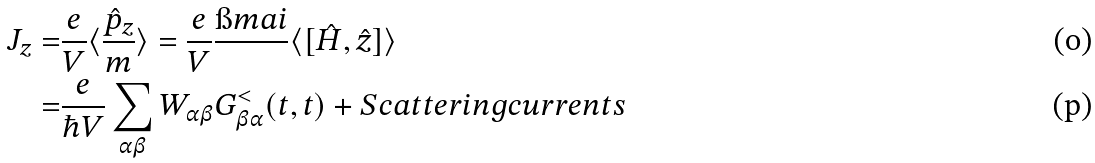Convert formula to latex. <formula><loc_0><loc_0><loc_500><loc_500>J _ { z } = & \frac { e } { V } \langle \frac { \hat { p } _ { z } } { m } \rangle = \frac { e } { V } \frac { \i m a i } { } \langle [ \hat { H } , \hat { z } ] \rangle \\ = & \frac { e } { \hbar { V } } \sum _ { \alpha \beta } W _ { \alpha \beta } G ^ { < } _ { \beta \alpha } ( t , t ) + S c a t t e r i n g c u r r e n t s</formula> 